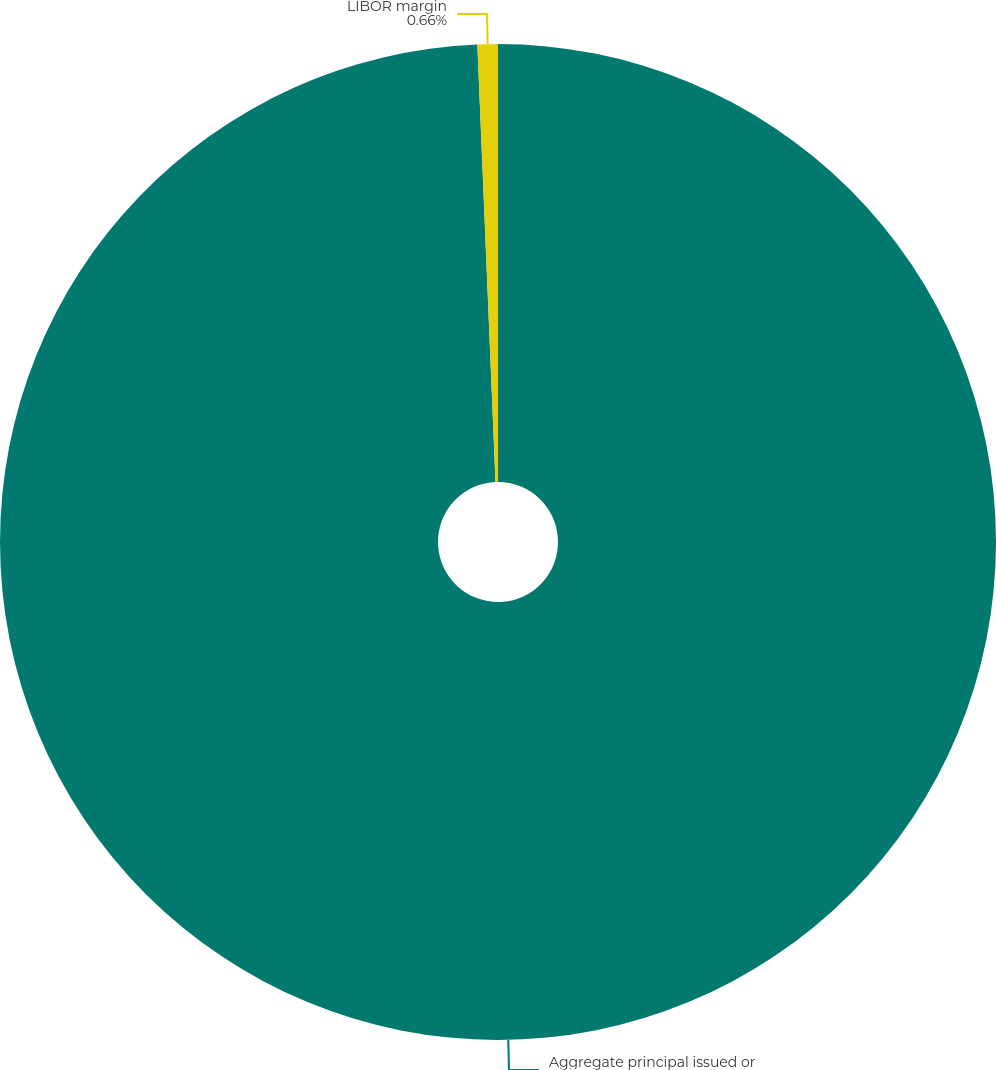<chart> <loc_0><loc_0><loc_500><loc_500><pie_chart><fcel>Aggregate principal issued or<fcel>LIBOR margin<nl><fcel>99.34%<fcel>0.66%<nl></chart> 